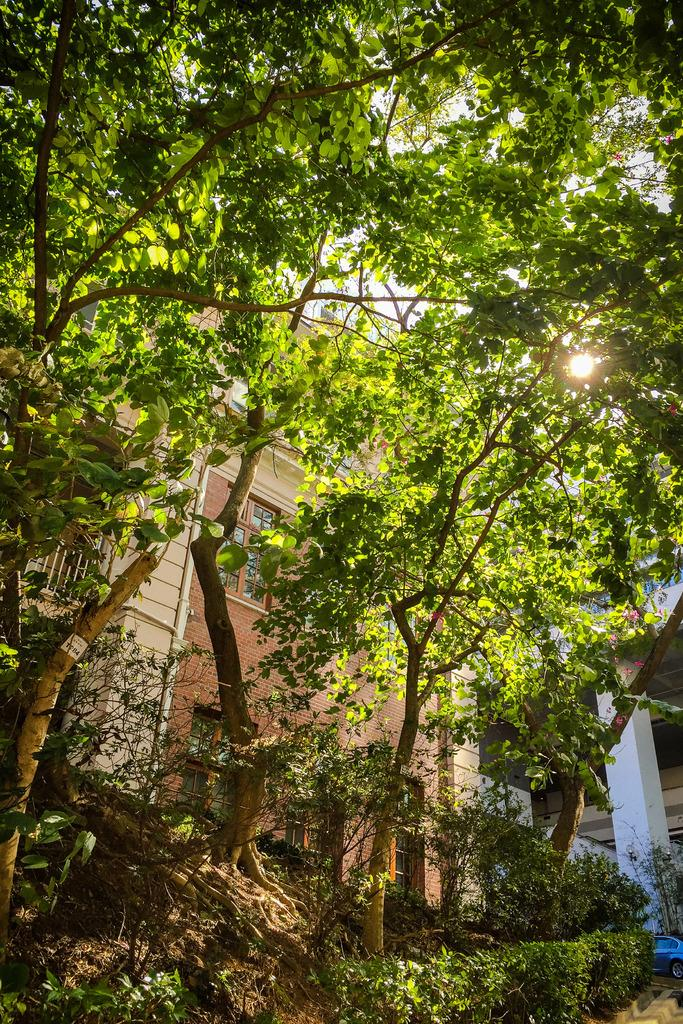What type of vegetation can be seen in the foreground of the image? There are trees in the foreground of the image. What type of structures are visible in the background of the image? There are houses in the background of the image. What object can be seen on the right side of the image? There is a pillar on the right side of the image. Where can the glue be found in the image? There is no glue present in the image. What type of activity is taking place at the camp in the image? There is no camp present in the image. 